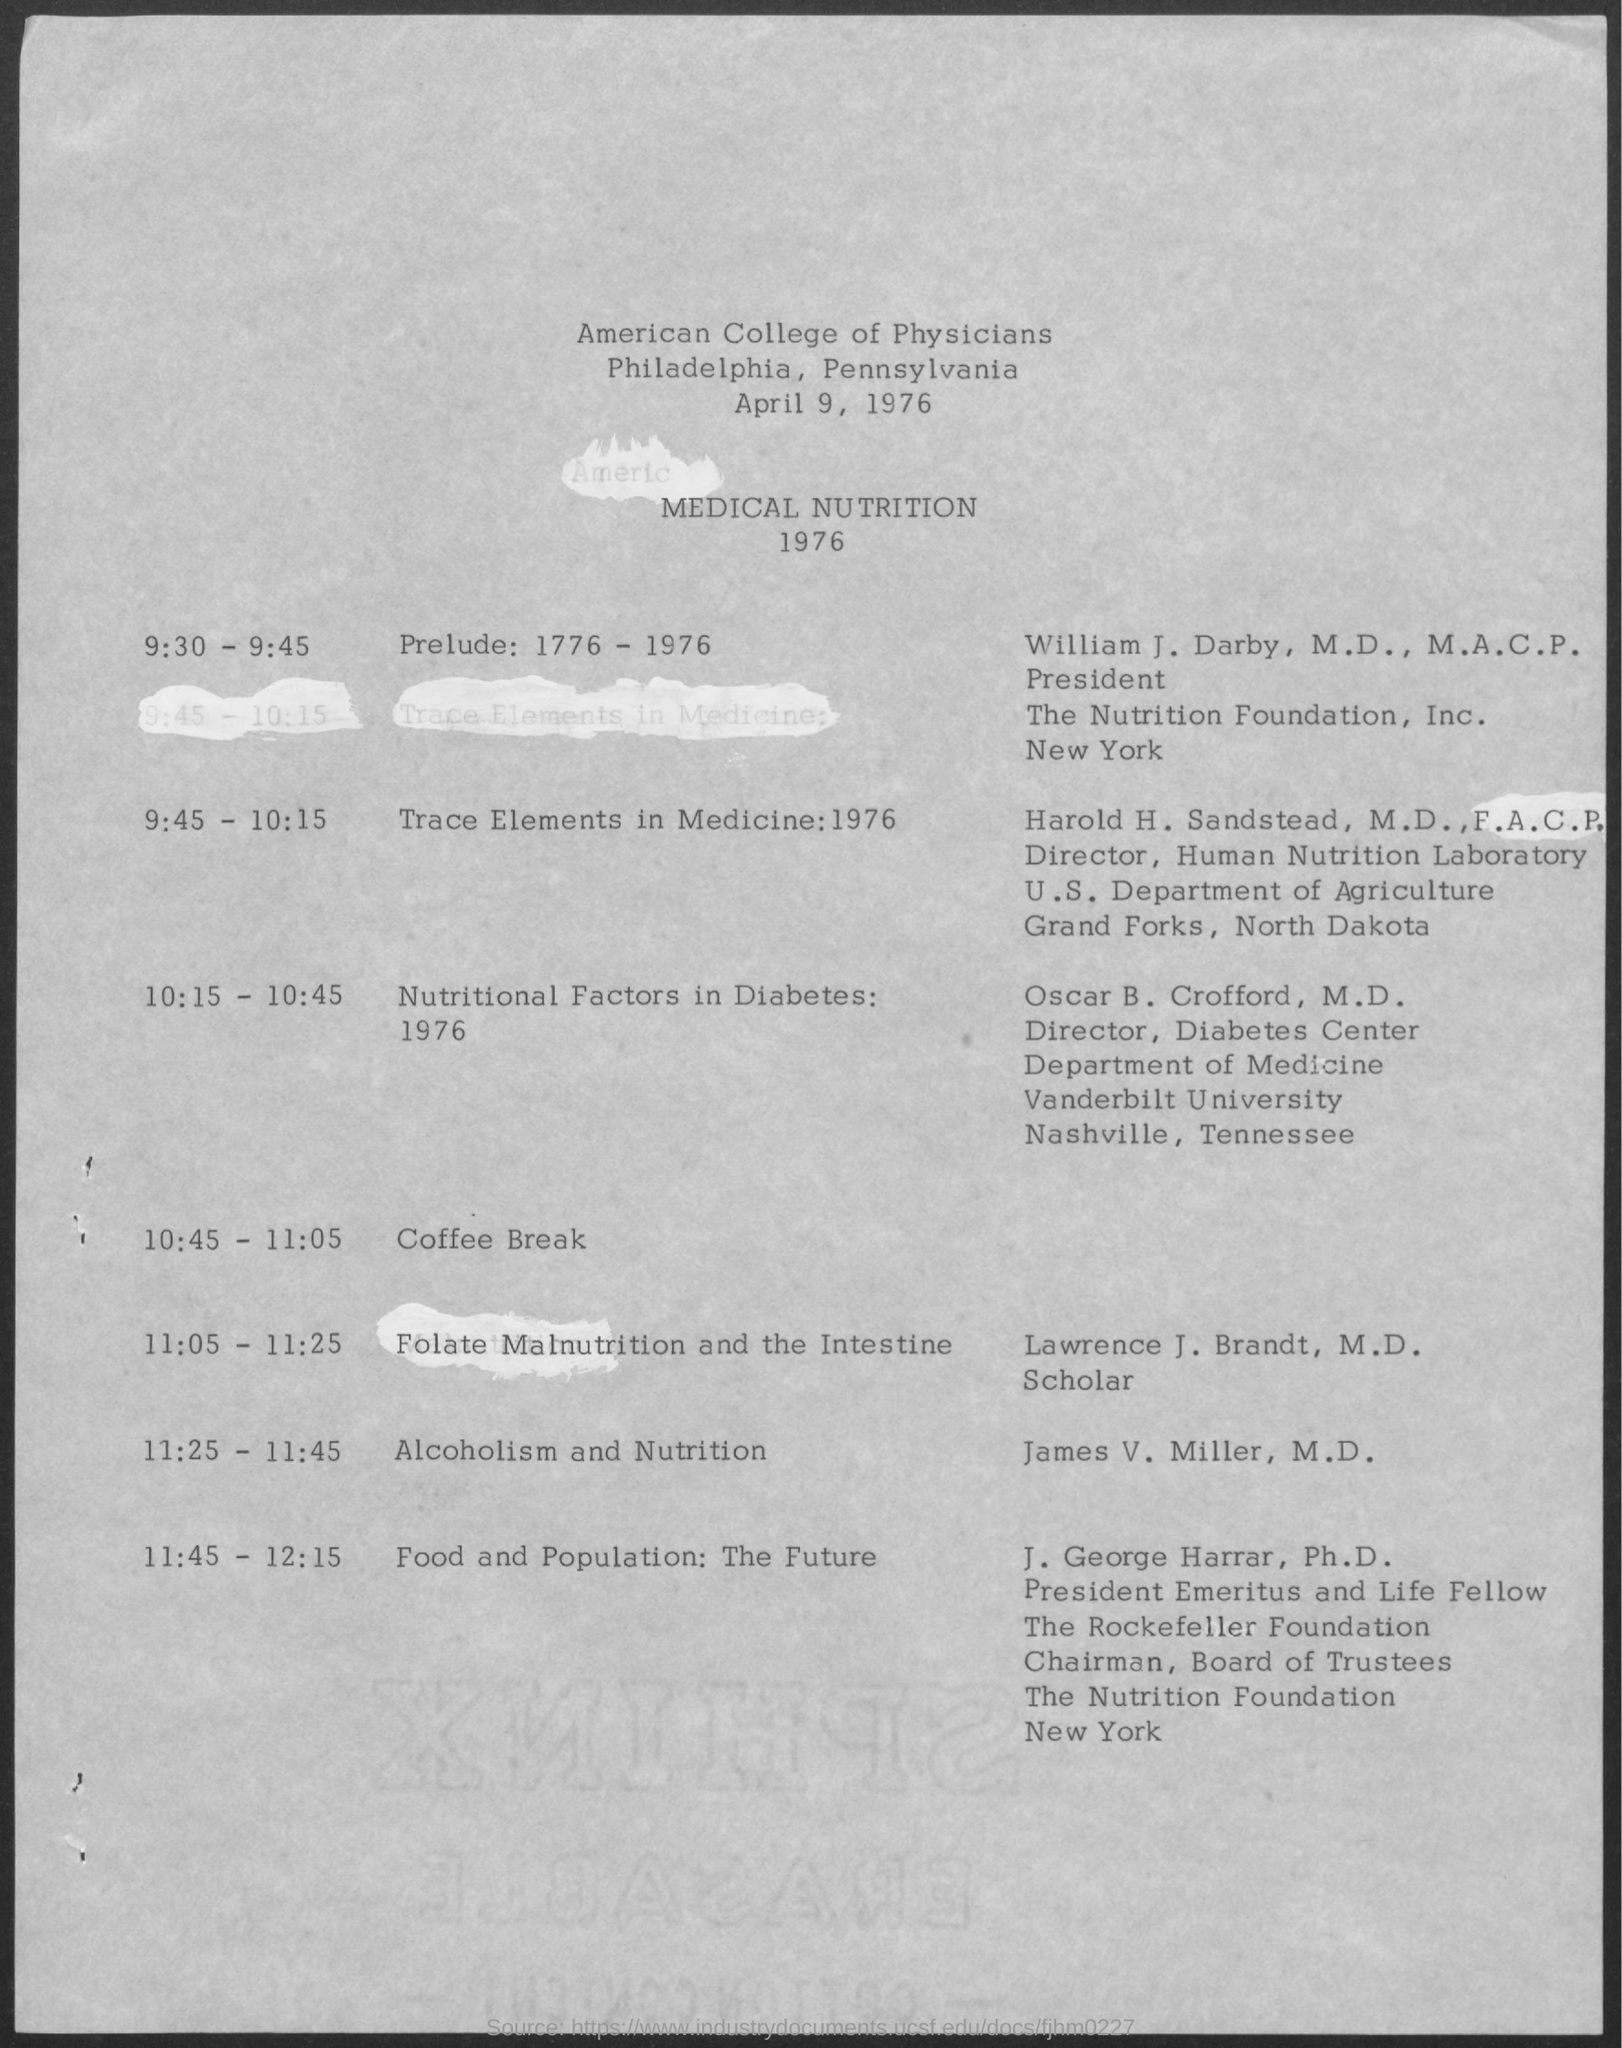Give some essential details in this illustration. The date mentioned is April 9, 1976. At 10:45 - 11:05, there was a coffee break. 